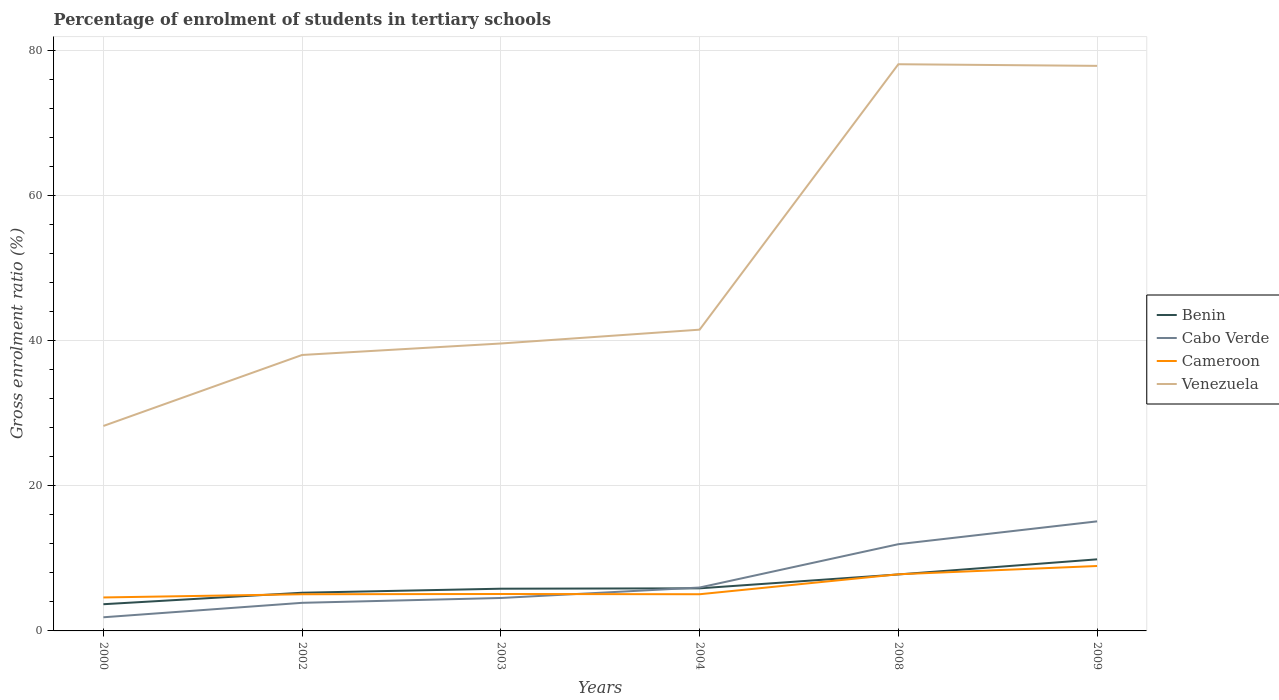Does the line corresponding to Cameroon intersect with the line corresponding to Venezuela?
Provide a succinct answer. No. Is the number of lines equal to the number of legend labels?
Provide a short and direct response. Yes. Across all years, what is the maximum percentage of students enrolled in tertiary schools in Venezuela?
Keep it short and to the point. 28.26. In which year was the percentage of students enrolled in tertiary schools in Venezuela maximum?
Give a very brief answer. 2000. What is the total percentage of students enrolled in tertiary schools in Venezuela in the graph?
Make the answer very short. -36.6. What is the difference between the highest and the second highest percentage of students enrolled in tertiary schools in Cameroon?
Make the answer very short. 4.34. What is the difference between the highest and the lowest percentage of students enrolled in tertiary schools in Benin?
Your answer should be very brief. 2. Is the percentage of students enrolled in tertiary schools in Cabo Verde strictly greater than the percentage of students enrolled in tertiary schools in Benin over the years?
Keep it short and to the point. No. How many lines are there?
Make the answer very short. 4. What is the difference between two consecutive major ticks on the Y-axis?
Your response must be concise. 20. How many legend labels are there?
Offer a terse response. 4. How are the legend labels stacked?
Provide a succinct answer. Vertical. What is the title of the graph?
Provide a succinct answer. Percentage of enrolment of students in tertiary schools. What is the label or title of the X-axis?
Your answer should be compact. Years. What is the label or title of the Y-axis?
Offer a terse response. Gross enrolment ratio (%). What is the Gross enrolment ratio (%) in Benin in 2000?
Provide a succinct answer. 3.68. What is the Gross enrolment ratio (%) in Cabo Verde in 2000?
Offer a terse response. 1.88. What is the Gross enrolment ratio (%) of Cameroon in 2000?
Keep it short and to the point. 4.61. What is the Gross enrolment ratio (%) of Venezuela in 2000?
Your answer should be compact. 28.26. What is the Gross enrolment ratio (%) of Benin in 2002?
Ensure brevity in your answer.  5.26. What is the Gross enrolment ratio (%) in Cabo Verde in 2002?
Provide a short and direct response. 3.87. What is the Gross enrolment ratio (%) of Cameroon in 2002?
Offer a very short reply. 5.06. What is the Gross enrolment ratio (%) of Venezuela in 2002?
Your response must be concise. 38.05. What is the Gross enrolment ratio (%) of Benin in 2003?
Offer a very short reply. 5.82. What is the Gross enrolment ratio (%) in Cabo Verde in 2003?
Ensure brevity in your answer.  4.54. What is the Gross enrolment ratio (%) in Cameroon in 2003?
Give a very brief answer. 5.09. What is the Gross enrolment ratio (%) in Venezuela in 2003?
Provide a short and direct response. 39.63. What is the Gross enrolment ratio (%) in Benin in 2004?
Your answer should be very brief. 5.87. What is the Gross enrolment ratio (%) in Cabo Verde in 2004?
Offer a terse response. 5.98. What is the Gross enrolment ratio (%) in Cameroon in 2004?
Ensure brevity in your answer.  5.06. What is the Gross enrolment ratio (%) of Venezuela in 2004?
Keep it short and to the point. 41.54. What is the Gross enrolment ratio (%) in Benin in 2008?
Your answer should be very brief. 7.79. What is the Gross enrolment ratio (%) of Cabo Verde in 2008?
Your response must be concise. 11.96. What is the Gross enrolment ratio (%) of Cameroon in 2008?
Offer a terse response. 7.81. What is the Gross enrolment ratio (%) in Venezuela in 2008?
Offer a terse response. 78.13. What is the Gross enrolment ratio (%) of Benin in 2009?
Offer a terse response. 9.87. What is the Gross enrolment ratio (%) of Cabo Verde in 2009?
Offer a terse response. 15.11. What is the Gross enrolment ratio (%) of Cameroon in 2009?
Offer a very short reply. 8.95. What is the Gross enrolment ratio (%) of Venezuela in 2009?
Offer a terse response. 77.91. Across all years, what is the maximum Gross enrolment ratio (%) in Benin?
Offer a terse response. 9.87. Across all years, what is the maximum Gross enrolment ratio (%) of Cabo Verde?
Give a very brief answer. 15.11. Across all years, what is the maximum Gross enrolment ratio (%) in Cameroon?
Keep it short and to the point. 8.95. Across all years, what is the maximum Gross enrolment ratio (%) in Venezuela?
Give a very brief answer. 78.13. Across all years, what is the minimum Gross enrolment ratio (%) of Benin?
Provide a short and direct response. 3.68. Across all years, what is the minimum Gross enrolment ratio (%) of Cabo Verde?
Offer a very short reply. 1.88. Across all years, what is the minimum Gross enrolment ratio (%) in Cameroon?
Provide a short and direct response. 4.61. Across all years, what is the minimum Gross enrolment ratio (%) in Venezuela?
Make the answer very short. 28.26. What is the total Gross enrolment ratio (%) of Benin in the graph?
Your answer should be very brief. 38.3. What is the total Gross enrolment ratio (%) in Cabo Verde in the graph?
Your answer should be compact. 43.35. What is the total Gross enrolment ratio (%) in Cameroon in the graph?
Ensure brevity in your answer.  36.58. What is the total Gross enrolment ratio (%) of Venezuela in the graph?
Ensure brevity in your answer.  303.52. What is the difference between the Gross enrolment ratio (%) of Benin in 2000 and that in 2002?
Your answer should be very brief. -1.58. What is the difference between the Gross enrolment ratio (%) of Cabo Verde in 2000 and that in 2002?
Make the answer very short. -1.99. What is the difference between the Gross enrolment ratio (%) in Cameroon in 2000 and that in 2002?
Keep it short and to the point. -0.44. What is the difference between the Gross enrolment ratio (%) of Venezuela in 2000 and that in 2002?
Provide a short and direct response. -9.79. What is the difference between the Gross enrolment ratio (%) in Benin in 2000 and that in 2003?
Provide a succinct answer. -2.14. What is the difference between the Gross enrolment ratio (%) of Cabo Verde in 2000 and that in 2003?
Your response must be concise. -2.66. What is the difference between the Gross enrolment ratio (%) in Cameroon in 2000 and that in 2003?
Provide a short and direct response. -0.48. What is the difference between the Gross enrolment ratio (%) in Venezuela in 2000 and that in 2003?
Make the answer very short. -11.37. What is the difference between the Gross enrolment ratio (%) in Benin in 2000 and that in 2004?
Your answer should be very brief. -2.19. What is the difference between the Gross enrolment ratio (%) in Cabo Verde in 2000 and that in 2004?
Give a very brief answer. -4.1. What is the difference between the Gross enrolment ratio (%) in Cameroon in 2000 and that in 2004?
Provide a short and direct response. -0.44. What is the difference between the Gross enrolment ratio (%) of Venezuela in 2000 and that in 2004?
Provide a short and direct response. -13.28. What is the difference between the Gross enrolment ratio (%) in Benin in 2000 and that in 2008?
Your answer should be compact. -4.11. What is the difference between the Gross enrolment ratio (%) of Cabo Verde in 2000 and that in 2008?
Give a very brief answer. -10.08. What is the difference between the Gross enrolment ratio (%) of Cameroon in 2000 and that in 2008?
Make the answer very short. -3.19. What is the difference between the Gross enrolment ratio (%) of Venezuela in 2000 and that in 2008?
Keep it short and to the point. -49.88. What is the difference between the Gross enrolment ratio (%) in Benin in 2000 and that in 2009?
Your response must be concise. -6.19. What is the difference between the Gross enrolment ratio (%) of Cabo Verde in 2000 and that in 2009?
Give a very brief answer. -13.22. What is the difference between the Gross enrolment ratio (%) of Cameroon in 2000 and that in 2009?
Ensure brevity in your answer.  -4.34. What is the difference between the Gross enrolment ratio (%) of Venezuela in 2000 and that in 2009?
Ensure brevity in your answer.  -49.65. What is the difference between the Gross enrolment ratio (%) of Benin in 2002 and that in 2003?
Your response must be concise. -0.56. What is the difference between the Gross enrolment ratio (%) of Cabo Verde in 2002 and that in 2003?
Give a very brief answer. -0.67. What is the difference between the Gross enrolment ratio (%) of Cameroon in 2002 and that in 2003?
Your response must be concise. -0.03. What is the difference between the Gross enrolment ratio (%) of Venezuela in 2002 and that in 2003?
Your answer should be compact. -1.58. What is the difference between the Gross enrolment ratio (%) of Benin in 2002 and that in 2004?
Your response must be concise. -0.61. What is the difference between the Gross enrolment ratio (%) in Cabo Verde in 2002 and that in 2004?
Your response must be concise. -2.11. What is the difference between the Gross enrolment ratio (%) in Cameroon in 2002 and that in 2004?
Offer a very short reply. -0. What is the difference between the Gross enrolment ratio (%) of Venezuela in 2002 and that in 2004?
Offer a terse response. -3.49. What is the difference between the Gross enrolment ratio (%) in Benin in 2002 and that in 2008?
Provide a short and direct response. -2.52. What is the difference between the Gross enrolment ratio (%) in Cabo Verde in 2002 and that in 2008?
Provide a short and direct response. -8.08. What is the difference between the Gross enrolment ratio (%) in Cameroon in 2002 and that in 2008?
Give a very brief answer. -2.75. What is the difference between the Gross enrolment ratio (%) in Venezuela in 2002 and that in 2008?
Make the answer very short. -40.09. What is the difference between the Gross enrolment ratio (%) of Benin in 2002 and that in 2009?
Your answer should be compact. -4.61. What is the difference between the Gross enrolment ratio (%) in Cabo Verde in 2002 and that in 2009?
Give a very brief answer. -11.23. What is the difference between the Gross enrolment ratio (%) in Cameroon in 2002 and that in 2009?
Give a very brief answer. -3.9. What is the difference between the Gross enrolment ratio (%) in Venezuela in 2002 and that in 2009?
Your response must be concise. -39.86. What is the difference between the Gross enrolment ratio (%) in Benin in 2003 and that in 2004?
Ensure brevity in your answer.  -0.05. What is the difference between the Gross enrolment ratio (%) of Cabo Verde in 2003 and that in 2004?
Your answer should be very brief. -1.44. What is the difference between the Gross enrolment ratio (%) of Cameroon in 2003 and that in 2004?
Provide a short and direct response. 0.03. What is the difference between the Gross enrolment ratio (%) of Venezuela in 2003 and that in 2004?
Your answer should be compact. -1.91. What is the difference between the Gross enrolment ratio (%) of Benin in 2003 and that in 2008?
Offer a terse response. -1.97. What is the difference between the Gross enrolment ratio (%) in Cabo Verde in 2003 and that in 2008?
Give a very brief answer. -7.42. What is the difference between the Gross enrolment ratio (%) in Cameroon in 2003 and that in 2008?
Provide a short and direct response. -2.72. What is the difference between the Gross enrolment ratio (%) of Venezuela in 2003 and that in 2008?
Your response must be concise. -38.51. What is the difference between the Gross enrolment ratio (%) in Benin in 2003 and that in 2009?
Provide a succinct answer. -4.05. What is the difference between the Gross enrolment ratio (%) in Cabo Verde in 2003 and that in 2009?
Ensure brevity in your answer.  -10.56. What is the difference between the Gross enrolment ratio (%) of Cameroon in 2003 and that in 2009?
Offer a very short reply. -3.86. What is the difference between the Gross enrolment ratio (%) in Venezuela in 2003 and that in 2009?
Provide a succinct answer. -38.28. What is the difference between the Gross enrolment ratio (%) of Benin in 2004 and that in 2008?
Keep it short and to the point. -1.92. What is the difference between the Gross enrolment ratio (%) of Cabo Verde in 2004 and that in 2008?
Give a very brief answer. -5.97. What is the difference between the Gross enrolment ratio (%) in Cameroon in 2004 and that in 2008?
Offer a terse response. -2.75. What is the difference between the Gross enrolment ratio (%) in Venezuela in 2004 and that in 2008?
Offer a very short reply. -36.6. What is the difference between the Gross enrolment ratio (%) in Benin in 2004 and that in 2009?
Ensure brevity in your answer.  -4. What is the difference between the Gross enrolment ratio (%) of Cabo Verde in 2004 and that in 2009?
Offer a terse response. -9.12. What is the difference between the Gross enrolment ratio (%) of Cameroon in 2004 and that in 2009?
Offer a terse response. -3.89. What is the difference between the Gross enrolment ratio (%) in Venezuela in 2004 and that in 2009?
Make the answer very short. -36.37. What is the difference between the Gross enrolment ratio (%) in Benin in 2008 and that in 2009?
Your response must be concise. -2.08. What is the difference between the Gross enrolment ratio (%) of Cabo Verde in 2008 and that in 2009?
Offer a terse response. -3.15. What is the difference between the Gross enrolment ratio (%) of Cameroon in 2008 and that in 2009?
Provide a short and direct response. -1.14. What is the difference between the Gross enrolment ratio (%) of Venezuela in 2008 and that in 2009?
Your answer should be compact. 0.23. What is the difference between the Gross enrolment ratio (%) of Benin in 2000 and the Gross enrolment ratio (%) of Cabo Verde in 2002?
Provide a short and direct response. -0.19. What is the difference between the Gross enrolment ratio (%) of Benin in 2000 and the Gross enrolment ratio (%) of Cameroon in 2002?
Ensure brevity in your answer.  -1.37. What is the difference between the Gross enrolment ratio (%) of Benin in 2000 and the Gross enrolment ratio (%) of Venezuela in 2002?
Provide a short and direct response. -34.37. What is the difference between the Gross enrolment ratio (%) of Cabo Verde in 2000 and the Gross enrolment ratio (%) of Cameroon in 2002?
Provide a short and direct response. -3.17. What is the difference between the Gross enrolment ratio (%) of Cabo Verde in 2000 and the Gross enrolment ratio (%) of Venezuela in 2002?
Keep it short and to the point. -36.17. What is the difference between the Gross enrolment ratio (%) in Cameroon in 2000 and the Gross enrolment ratio (%) in Venezuela in 2002?
Give a very brief answer. -33.43. What is the difference between the Gross enrolment ratio (%) of Benin in 2000 and the Gross enrolment ratio (%) of Cabo Verde in 2003?
Your answer should be very brief. -0.86. What is the difference between the Gross enrolment ratio (%) in Benin in 2000 and the Gross enrolment ratio (%) in Cameroon in 2003?
Your response must be concise. -1.41. What is the difference between the Gross enrolment ratio (%) in Benin in 2000 and the Gross enrolment ratio (%) in Venezuela in 2003?
Provide a succinct answer. -35.95. What is the difference between the Gross enrolment ratio (%) in Cabo Verde in 2000 and the Gross enrolment ratio (%) in Cameroon in 2003?
Make the answer very short. -3.21. What is the difference between the Gross enrolment ratio (%) of Cabo Verde in 2000 and the Gross enrolment ratio (%) of Venezuela in 2003?
Provide a succinct answer. -37.75. What is the difference between the Gross enrolment ratio (%) of Cameroon in 2000 and the Gross enrolment ratio (%) of Venezuela in 2003?
Your answer should be very brief. -35.01. What is the difference between the Gross enrolment ratio (%) of Benin in 2000 and the Gross enrolment ratio (%) of Cabo Verde in 2004?
Offer a very short reply. -2.3. What is the difference between the Gross enrolment ratio (%) of Benin in 2000 and the Gross enrolment ratio (%) of Cameroon in 2004?
Ensure brevity in your answer.  -1.38. What is the difference between the Gross enrolment ratio (%) of Benin in 2000 and the Gross enrolment ratio (%) of Venezuela in 2004?
Your answer should be very brief. -37.86. What is the difference between the Gross enrolment ratio (%) in Cabo Verde in 2000 and the Gross enrolment ratio (%) in Cameroon in 2004?
Your response must be concise. -3.18. What is the difference between the Gross enrolment ratio (%) of Cabo Verde in 2000 and the Gross enrolment ratio (%) of Venezuela in 2004?
Offer a terse response. -39.66. What is the difference between the Gross enrolment ratio (%) of Cameroon in 2000 and the Gross enrolment ratio (%) of Venezuela in 2004?
Your response must be concise. -36.92. What is the difference between the Gross enrolment ratio (%) in Benin in 2000 and the Gross enrolment ratio (%) in Cabo Verde in 2008?
Give a very brief answer. -8.28. What is the difference between the Gross enrolment ratio (%) of Benin in 2000 and the Gross enrolment ratio (%) of Cameroon in 2008?
Your answer should be compact. -4.13. What is the difference between the Gross enrolment ratio (%) in Benin in 2000 and the Gross enrolment ratio (%) in Venezuela in 2008?
Your answer should be compact. -74.45. What is the difference between the Gross enrolment ratio (%) in Cabo Verde in 2000 and the Gross enrolment ratio (%) in Cameroon in 2008?
Your answer should be compact. -5.93. What is the difference between the Gross enrolment ratio (%) of Cabo Verde in 2000 and the Gross enrolment ratio (%) of Venezuela in 2008?
Provide a short and direct response. -76.25. What is the difference between the Gross enrolment ratio (%) of Cameroon in 2000 and the Gross enrolment ratio (%) of Venezuela in 2008?
Your response must be concise. -73.52. What is the difference between the Gross enrolment ratio (%) in Benin in 2000 and the Gross enrolment ratio (%) in Cabo Verde in 2009?
Your answer should be compact. -11.43. What is the difference between the Gross enrolment ratio (%) of Benin in 2000 and the Gross enrolment ratio (%) of Cameroon in 2009?
Offer a very short reply. -5.27. What is the difference between the Gross enrolment ratio (%) in Benin in 2000 and the Gross enrolment ratio (%) in Venezuela in 2009?
Make the answer very short. -74.23. What is the difference between the Gross enrolment ratio (%) of Cabo Verde in 2000 and the Gross enrolment ratio (%) of Cameroon in 2009?
Provide a succinct answer. -7.07. What is the difference between the Gross enrolment ratio (%) of Cabo Verde in 2000 and the Gross enrolment ratio (%) of Venezuela in 2009?
Offer a very short reply. -76.03. What is the difference between the Gross enrolment ratio (%) of Cameroon in 2000 and the Gross enrolment ratio (%) of Venezuela in 2009?
Provide a short and direct response. -73.3. What is the difference between the Gross enrolment ratio (%) in Benin in 2002 and the Gross enrolment ratio (%) in Cabo Verde in 2003?
Ensure brevity in your answer.  0.72. What is the difference between the Gross enrolment ratio (%) of Benin in 2002 and the Gross enrolment ratio (%) of Cameroon in 2003?
Your answer should be compact. 0.17. What is the difference between the Gross enrolment ratio (%) in Benin in 2002 and the Gross enrolment ratio (%) in Venezuela in 2003?
Give a very brief answer. -34.36. What is the difference between the Gross enrolment ratio (%) in Cabo Verde in 2002 and the Gross enrolment ratio (%) in Cameroon in 2003?
Give a very brief answer. -1.22. What is the difference between the Gross enrolment ratio (%) of Cabo Verde in 2002 and the Gross enrolment ratio (%) of Venezuela in 2003?
Offer a very short reply. -35.75. What is the difference between the Gross enrolment ratio (%) in Cameroon in 2002 and the Gross enrolment ratio (%) in Venezuela in 2003?
Your response must be concise. -34.57. What is the difference between the Gross enrolment ratio (%) in Benin in 2002 and the Gross enrolment ratio (%) in Cabo Verde in 2004?
Provide a short and direct response. -0.72. What is the difference between the Gross enrolment ratio (%) in Benin in 2002 and the Gross enrolment ratio (%) in Cameroon in 2004?
Ensure brevity in your answer.  0.21. What is the difference between the Gross enrolment ratio (%) of Benin in 2002 and the Gross enrolment ratio (%) of Venezuela in 2004?
Provide a short and direct response. -36.27. What is the difference between the Gross enrolment ratio (%) of Cabo Verde in 2002 and the Gross enrolment ratio (%) of Cameroon in 2004?
Provide a short and direct response. -1.18. What is the difference between the Gross enrolment ratio (%) in Cabo Verde in 2002 and the Gross enrolment ratio (%) in Venezuela in 2004?
Offer a very short reply. -37.66. What is the difference between the Gross enrolment ratio (%) of Cameroon in 2002 and the Gross enrolment ratio (%) of Venezuela in 2004?
Ensure brevity in your answer.  -36.48. What is the difference between the Gross enrolment ratio (%) in Benin in 2002 and the Gross enrolment ratio (%) in Cabo Verde in 2008?
Keep it short and to the point. -6.69. What is the difference between the Gross enrolment ratio (%) in Benin in 2002 and the Gross enrolment ratio (%) in Cameroon in 2008?
Provide a succinct answer. -2.54. What is the difference between the Gross enrolment ratio (%) in Benin in 2002 and the Gross enrolment ratio (%) in Venezuela in 2008?
Offer a terse response. -72.87. What is the difference between the Gross enrolment ratio (%) of Cabo Verde in 2002 and the Gross enrolment ratio (%) of Cameroon in 2008?
Your response must be concise. -3.93. What is the difference between the Gross enrolment ratio (%) of Cabo Verde in 2002 and the Gross enrolment ratio (%) of Venezuela in 2008?
Your answer should be very brief. -74.26. What is the difference between the Gross enrolment ratio (%) in Cameroon in 2002 and the Gross enrolment ratio (%) in Venezuela in 2008?
Keep it short and to the point. -73.08. What is the difference between the Gross enrolment ratio (%) of Benin in 2002 and the Gross enrolment ratio (%) of Cabo Verde in 2009?
Make the answer very short. -9.84. What is the difference between the Gross enrolment ratio (%) in Benin in 2002 and the Gross enrolment ratio (%) in Cameroon in 2009?
Offer a terse response. -3.69. What is the difference between the Gross enrolment ratio (%) of Benin in 2002 and the Gross enrolment ratio (%) of Venezuela in 2009?
Provide a short and direct response. -72.64. What is the difference between the Gross enrolment ratio (%) in Cabo Verde in 2002 and the Gross enrolment ratio (%) in Cameroon in 2009?
Your answer should be compact. -5.08. What is the difference between the Gross enrolment ratio (%) in Cabo Verde in 2002 and the Gross enrolment ratio (%) in Venezuela in 2009?
Your answer should be compact. -74.03. What is the difference between the Gross enrolment ratio (%) in Cameroon in 2002 and the Gross enrolment ratio (%) in Venezuela in 2009?
Offer a terse response. -72.85. What is the difference between the Gross enrolment ratio (%) of Benin in 2003 and the Gross enrolment ratio (%) of Cabo Verde in 2004?
Your answer should be very brief. -0.16. What is the difference between the Gross enrolment ratio (%) in Benin in 2003 and the Gross enrolment ratio (%) in Cameroon in 2004?
Your answer should be compact. 0.76. What is the difference between the Gross enrolment ratio (%) of Benin in 2003 and the Gross enrolment ratio (%) of Venezuela in 2004?
Make the answer very short. -35.72. What is the difference between the Gross enrolment ratio (%) in Cabo Verde in 2003 and the Gross enrolment ratio (%) in Cameroon in 2004?
Offer a very short reply. -0.52. What is the difference between the Gross enrolment ratio (%) of Cabo Verde in 2003 and the Gross enrolment ratio (%) of Venezuela in 2004?
Your response must be concise. -37. What is the difference between the Gross enrolment ratio (%) in Cameroon in 2003 and the Gross enrolment ratio (%) in Venezuela in 2004?
Offer a very short reply. -36.45. What is the difference between the Gross enrolment ratio (%) in Benin in 2003 and the Gross enrolment ratio (%) in Cabo Verde in 2008?
Offer a terse response. -6.14. What is the difference between the Gross enrolment ratio (%) in Benin in 2003 and the Gross enrolment ratio (%) in Cameroon in 2008?
Give a very brief answer. -1.99. What is the difference between the Gross enrolment ratio (%) in Benin in 2003 and the Gross enrolment ratio (%) in Venezuela in 2008?
Offer a terse response. -72.31. What is the difference between the Gross enrolment ratio (%) in Cabo Verde in 2003 and the Gross enrolment ratio (%) in Cameroon in 2008?
Make the answer very short. -3.27. What is the difference between the Gross enrolment ratio (%) in Cabo Verde in 2003 and the Gross enrolment ratio (%) in Venezuela in 2008?
Offer a terse response. -73.59. What is the difference between the Gross enrolment ratio (%) in Cameroon in 2003 and the Gross enrolment ratio (%) in Venezuela in 2008?
Ensure brevity in your answer.  -73.04. What is the difference between the Gross enrolment ratio (%) in Benin in 2003 and the Gross enrolment ratio (%) in Cabo Verde in 2009?
Give a very brief answer. -9.29. What is the difference between the Gross enrolment ratio (%) in Benin in 2003 and the Gross enrolment ratio (%) in Cameroon in 2009?
Ensure brevity in your answer.  -3.13. What is the difference between the Gross enrolment ratio (%) in Benin in 2003 and the Gross enrolment ratio (%) in Venezuela in 2009?
Make the answer very short. -72.09. What is the difference between the Gross enrolment ratio (%) in Cabo Verde in 2003 and the Gross enrolment ratio (%) in Cameroon in 2009?
Give a very brief answer. -4.41. What is the difference between the Gross enrolment ratio (%) of Cabo Verde in 2003 and the Gross enrolment ratio (%) of Venezuela in 2009?
Give a very brief answer. -73.37. What is the difference between the Gross enrolment ratio (%) of Cameroon in 2003 and the Gross enrolment ratio (%) of Venezuela in 2009?
Your answer should be very brief. -72.82. What is the difference between the Gross enrolment ratio (%) in Benin in 2004 and the Gross enrolment ratio (%) in Cabo Verde in 2008?
Offer a very short reply. -6.09. What is the difference between the Gross enrolment ratio (%) in Benin in 2004 and the Gross enrolment ratio (%) in Cameroon in 2008?
Provide a succinct answer. -1.94. What is the difference between the Gross enrolment ratio (%) in Benin in 2004 and the Gross enrolment ratio (%) in Venezuela in 2008?
Your answer should be compact. -72.26. What is the difference between the Gross enrolment ratio (%) of Cabo Verde in 2004 and the Gross enrolment ratio (%) of Cameroon in 2008?
Offer a very short reply. -1.82. What is the difference between the Gross enrolment ratio (%) of Cabo Verde in 2004 and the Gross enrolment ratio (%) of Venezuela in 2008?
Keep it short and to the point. -72.15. What is the difference between the Gross enrolment ratio (%) of Cameroon in 2004 and the Gross enrolment ratio (%) of Venezuela in 2008?
Your answer should be very brief. -73.08. What is the difference between the Gross enrolment ratio (%) in Benin in 2004 and the Gross enrolment ratio (%) in Cabo Verde in 2009?
Provide a succinct answer. -9.23. What is the difference between the Gross enrolment ratio (%) of Benin in 2004 and the Gross enrolment ratio (%) of Cameroon in 2009?
Your answer should be very brief. -3.08. What is the difference between the Gross enrolment ratio (%) in Benin in 2004 and the Gross enrolment ratio (%) in Venezuela in 2009?
Make the answer very short. -72.04. What is the difference between the Gross enrolment ratio (%) in Cabo Verde in 2004 and the Gross enrolment ratio (%) in Cameroon in 2009?
Your answer should be compact. -2.97. What is the difference between the Gross enrolment ratio (%) in Cabo Verde in 2004 and the Gross enrolment ratio (%) in Venezuela in 2009?
Provide a succinct answer. -71.93. What is the difference between the Gross enrolment ratio (%) of Cameroon in 2004 and the Gross enrolment ratio (%) of Venezuela in 2009?
Give a very brief answer. -72.85. What is the difference between the Gross enrolment ratio (%) in Benin in 2008 and the Gross enrolment ratio (%) in Cabo Verde in 2009?
Provide a succinct answer. -7.32. What is the difference between the Gross enrolment ratio (%) in Benin in 2008 and the Gross enrolment ratio (%) in Cameroon in 2009?
Keep it short and to the point. -1.16. What is the difference between the Gross enrolment ratio (%) of Benin in 2008 and the Gross enrolment ratio (%) of Venezuela in 2009?
Give a very brief answer. -70.12. What is the difference between the Gross enrolment ratio (%) of Cabo Verde in 2008 and the Gross enrolment ratio (%) of Cameroon in 2009?
Keep it short and to the point. 3.01. What is the difference between the Gross enrolment ratio (%) in Cabo Verde in 2008 and the Gross enrolment ratio (%) in Venezuela in 2009?
Your answer should be very brief. -65.95. What is the difference between the Gross enrolment ratio (%) of Cameroon in 2008 and the Gross enrolment ratio (%) of Venezuela in 2009?
Make the answer very short. -70.1. What is the average Gross enrolment ratio (%) in Benin per year?
Provide a succinct answer. 6.38. What is the average Gross enrolment ratio (%) in Cabo Verde per year?
Offer a very short reply. 7.22. What is the average Gross enrolment ratio (%) in Cameroon per year?
Keep it short and to the point. 6.1. What is the average Gross enrolment ratio (%) in Venezuela per year?
Your answer should be compact. 50.59. In the year 2000, what is the difference between the Gross enrolment ratio (%) in Benin and Gross enrolment ratio (%) in Cabo Verde?
Keep it short and to the point. 1.8. In the year 2000, what is the difference between the Gross enrolment ratio (%) in Benin and Gross enrolment ratio (%) in Cameroon?
Your answer should be very brief. -0.93. In the year 2000, what is the difference between the Gross enrolment ratio (%) of Benin and Gross enrolment ratio (%) of Venezuela?
Provide a short and direct response. -24.58. In the year 2000, what is the difference between the Gross enrolment ratio (%) in Cabo Verde and Gross enrolment ratio (%) in Cameroon?
Your response must be concise. -2.73. In the year 2000, what is the difference between the Gross enrolment ratio (%) of Cabo Verde and Gross enrolment ratio (%) of Venezuela?
Keep it short and to the point. -26.38. In the year 2000, what is the difference between the Gross enrolment ratio (%) in Cameroon and Gross enrolment ratio (%) in Venezuela?
Ensure brevity in your answer.  -23.64. In the year 2002, what is the difference between the Gross enrolment ratio (%) in Benin and Gross enrolment ratio (%) in Cabo Verde?
Your answer should be compact. 1.39. In the year 2002, what is the difference between the Gross enrolment ratio (%) of Benin and Gross enrolment ratio (%) of Cameroon?
Ensure brevity in your answer.  0.21. In the year 2002, what is the difference between the Gross enrolment ratio (%) in Benin and Gross enrolment ratio (%) in Venezuela?
Give a very brief answer. -32.78. In the year 2002, what is the difference between the Gross enrolment ratio (%) of Cabo Verde and Gross enrolment ratio (%) of Cameroon?
Provide a succinct answer. -1.18. In the year 2002, what is the difference between the Gross enrolment ratio (%) in Cabo Verde and Gross enrolment ratio (%) in Venezuela?
Keep it short and to the point. -34.17. In the year 2002, what is the difference between the Gross enrolment ratio (%) of Cameroon and Gross enrolment ratio (%) of Venezuela?
Your answer should be very brief. -32.99. In the year 2003, what is the difference between the Gross enrolment ratio (%) in Benin and Gross enrolment ratio (%) in Cabo Verde?
Your answer should be very brief. 1.28. In the year 2003, what is the difference between the Gross enrolment ratio (%) of Benin and Gross enrolment ratio (%) of Cameroon?
Your answer should be compact. 0.73. In the year 2003, what is the difference between the Gross enrolment ratio (%) of Benin and Gross enrolment ratio (%) of Venezuela?
Give a very brief answer. -33.81. In the year 2003, what is the difference between the Gross enrolment ratio (%) in Cabo Verde and Gross enrolment ratio (%) in Cameroon?
Your answer should be very brief. -0.55. In the year 2003, what is the difference between the Gross enrolment ratio (%) of Cabo Verde and Gross enrolment ratio (%) of Venezuela?
Ensure brevity in your answer.  -35.09. In the year 2003, what is the difference between the Gross enrolment ratio (%) in Cameroon and Gross enrolment ratio (%) in Venezuela?
Your answer should be very brief. -34.54. In the year 2004, what is the difference between the Gross enrolment ratio (%) of Benin and Gross enrolment ratio (%) of Cabo Verde?
Provide a succinct answer. -0.11. In the year 2004, what is the difference between the Gross enrolment ratio (%) in Benin and Gross enrolment ratio (%) in Cameroon?
Your response must be concise. 0.81. In the year 2004, what is the difference between the Gross enrolment ratio (%) of Benin and Gross enrolment ratio (%) of Venezuela?
Give a very brief answer. -35.66. In the year 2004, what is the difference between the Gross enrolment ratio (%) of Cabo Verde and Gross enrolment ratio (%) of Cameroon?
Offer a very short reply. 0.93. In the year 2004, what is the difference between the Gross enrolment ratio (%) in Cabo Verde and Gross enrolment ratio (%) in Venezuela?
Your answer should be compact. -35.55. In the year 2004, what is the difference between the Gross enrolment ratio (%) of Cameroon and Gross enrolment ratio (%) of Venezuela?
Offer a terse response. -36.48. In the year 2008, what is the difference between the Gross enrolment ratio (%) of Benin and Gross enrolment ratio (%) of Cabo Verde?
Your response must be concise. -4.17. In the year 2008, what is the difference between the Gross enrolment ratio (%) of Benin and Gross enrolment ratio (%) of Cameroon?
Your answer should be very brief. -0.02. In the year 2008, what is the difference between the Gross enrolment ratio (%) in Benin and Gross enrolment ratio (%) in Venezuela?
Keep it short and to the point. -70.35. In the year 2008, what is the difference between the Gross enrolment ratio (%) in Cabo Verde and Gross enrolment ratio (%) in Cameroon?
Your answer should be very brief. 4.15. In the year 2008, what is the difference between the Gross enrolment ratio (%) of Cabo Verde and Gross enrolment ratio (%) of Venezuela?
Give a very brief answer. -66.18. In the year 2008, what is the difference between the Gross enrolment ratio (%) of Cameroon and Gross enrolment ratio (%) of Venezuela?
Your answer should be compact. -70.33. In the year 2009, what is the difference between the Gross enrolment ratio (%) of Benin and Gross enrolment ratio (%) of Cabo Verde?
Your answer should be compact. -5.24. In the year 2009, what is the difference between the Gross enrolment ratio (%) in Benin and Gross enrolment ratio (%) in Cameroon?
Make the answer very short. 0.92. In the year 2009, what is the difference between the Gross enrolment ratio (%) in Benin and Gross enrolment ratio (%) in Venezuela?
Ensure brevity in your answer.  -68.04. In the year 2009, what is the difference between the Gross enrolment ratio (%) in Cabo Verde and Gross enrolment ratio (%) in Cameroon?
Give a very brief answer. 6.15. In the year 2009, what is the difference between the Gross enrolment ratio (%) in Cabo Verde and Gross enrolment ratio (%) in Venezuela?
Give a very brief answer. -62.8. In the year 2009, what is the difference between the Gross enrolment ratio (%) of Cameroon and Gross enrolment ratio (%) of Venezuela?
Offer a very short reply. -68.96. What is the ratio of the Gross enrolment ratio (%) in Benin in 2000 to that in 2002?
Ensure brevity in your answer.  0.7. What is the ratio of the Gross enrolment ratio (%) in Cabo Verde in 2000 to that in 2002?
Your answer should be compact. 0.49. What is the ratio of the Gross enrolment ratio (%) of Cameroon in 2000 to that in 2002?
Make the answer very short. 0.91. What is the ratio of the Gross enrolment ratio (%) of Venezuela in 2000 to that in 2002?
Ensure brevity in your answer.  0.74. What is the ratio of the Gross enrolment ratio (%) of Benin in 2000 to that in 2003?
Offer a very short reply. 0.63. What is the ratio of the Gross enrolment ratio (%) in Cabo Verde in 2000 to that in 2003?
Keep it short and to the point. 0.41. What is the ratio of the Gross enrolment ratio (%) of Cameroon in 2000 to that in 2003?
Provide a succinct answer. 0.91. What is the ratio of the Gross enrolment ratio (%) in Venezuela in 2000 to that in 2003?
Give a very brief answer. 0.71. What is the ratio of the Gross enrolment ratio (%) in Benin in 2000 to that in 2004?
Your response must be concise. 0.63. What is the ratio of the Gross enrolment ratio (%) in Cabo Verde in 2000 to that in 2004?
Your answer should be very brief. 0.31. What is the ratio of the Gross enrolment ratio (%) in Cameroon in 2000 to that in 2004?
Your answer should be compact. 0.91. What is the ratio of the Gross enrolment ratio (%) of Venezuela in 2000 to that in 2004?
Give a very brief answer. 0.68. What is the ratio of the Gross enrolment ratio (%) in Benin in 2000 to that in 2008?
Your answer should be compact. 0.47. What is the ratio of the Gross enrolment ratio (%) of Cabo Verde in 2000 to that in 2008?
Offer a terse response. 0.16. What is the ratio of the Gross enrolment ratio (%) of Cameroon in 2000 to that in 2008?
Provide a short and direct response. 0.59. What is the ratio of the Gross enrolment ratio (%) of Venezuela in 2000 to that in 2008?
Give a very brief answer. 0.36. What is the ratio of the Gross enrolment ratio (%) of Benin in 2000 to that in 2009?
Your answer should be compact. 0.37. What is the ratio of the Gross enrolment ratio (%) of Cabo Verde in 2000 to that in 2009?
Keep it short and to the point. 0.12. What is the ratio of the Gross enrolment ratio (%) in Cameroon in 2000 to that in 2009?
Keep it short and to the point. 0.52. What is the ratio of the Gross enrolment ratio (%) of Venezuela in 2000 to that in 2009?
Your answer should be very brief. 0.36. What is the ratio of the Gross enrolment ratio (%) of Benin in 2002 to that in 2003?
Offer a terse response. 0.9. What is the ratio of the Gross enrolment ratio (%) of Cabo Verde in 2002 to that in 2003?
Give a very brief answer. 0.85. What is the ratio of the Gross enrolment ratio (%) of Cameroon in 2002 to that in 2003?
Your response must be concise. 0.99. What is the ratio of the Gross enrolment ratio (%) in Venezuela in 2002 to that in 2003?
Keep it short and to the point. 0.96. What is the ratio of the Gross enrolment ratio (%) of Benin in 2002 to that in 2004?
Provide a succinct answer. 0.9. What is the ratio of the Gross enrolment ratio (%) in Cabo Verde in 2002 to that in 2004?
Provide a short and direct response. 0.65. What is the ratio of the Gross enrolment ratio (%) in Cameroon in 2002 to that in 2004?
Provide a short and direct response. 1. What is the ratio of the Gross enrolment ratio (%) in Venezuela in 2002 to that in 2004?
Your answer should be very brief. 0.92. What is the ratio of the Gross enrolment ratio (%) in Benin in 2002 to that in 2008?
Your answer should be compact. 0.68. What is the ratio of the Gross enrolment ratio (%) of Cabo Verde in 2002 to that in 2008?
Provide a succinct answer. 0.32. What is the ratio of the Gross enrolment ratio (%) in Cameroon in 2002 to that in 2008?
Offer a very short reply. 0.65. What is the ratio of the Gross enrolment ratio (%) in Venezuela in 2002 to that in 2008?
Make the answer very short. 0.49. What is the ratio of the Gross enrolment ratio (%) of Benin in 2002 to that in 2009?
Offer a terse response. 0.53. What is the ratio of the Gross enrolment ratio (%) in Cabo Verde in 2002 to that in 2009?
Your response must be concise. 0.26. What is the ratio of the Gross enrolment ratio (%) of Cameroon in 2002 to that in 2009?
Make the answer very short. 0.56. What is the ratio of the Gross enrolment ratio (%) in Venezuela in 2002 to that in 2009?
Your response must be concise. 0.49. What is the ratio of the Gross enrolment ratio (%) of Benin in 2003 to that in 2004?
Offer a terse response. 0.99. What is the ratio of the Gross enrolment ratio (%) of Cabo Verde in 2003 to that in 2004?
Your response must be concise. 0.76. What is the ratio of the Gross enrolment ratio (%) of Cameroon in 2003 to that in 2004?
Your answer should be compact. 1.01. What is the ratio of the Gross enrolment ratio (%) in Venezuela in 2003 to that in 2004?
Your answer should be compact. 0.95. What is the ratio of the Gross enrolment ratio (%) of Benin in 2003 to that in 2008?
Give a very brief answer. 0.75. What is the ratio of the Gross enrolment ratio (%) of Cabo Verde in 2003 to that in 2008?
Give a very brief answer. 0.38. What is the ratio of the Gross enrolment ratio (%) of Cameroon in 2003 to that in 2008?
Offer a very short reply. 0.65. What is the ratio of the Gross enrolment ratio (%) of Venezuela in 2003 to that in 2008?
Give a very brief answer. 0.51. What is the ratio of the Gross enrolment ratio (%) of Benin in 2003 to that in 2009?
Keep it short and to the point. 0.59. What is the ratio of the Gross enrolment ratio (%) of Cabo Verde in 2003 to that in 2009?
Ensure brevity in your answer.  0.3. What is the ratio of the Gross enrolment ratio (%) of Cameroon in 2003 to that in 2009?
Your answer should be very brief. 0.57. What is the ratio of the Gross enrolment ratio (%) in Venezuela in 2003 to that in 2009?
Provide a succinct answer. 0.51. What is the ratio of the Gross enrolment ratio (%) in Benin in 2004 to that in 2008?
Your answer should be compact. 0.75. What is the ratio of the Gross enrolment ratio (%) of Cabo Verde in 2004 to that in 2008?
Ensure brevity in your answer.  0.5. What is the ratio of the Gross enrolment ratio (%) of Cameroon in 2004 to that in 2008?
Keep it short and to the point. 0.65. What is the ratio of the Gross enrolment ratio (%) of Venezuela in 2004 to that in 2008?
Ensure brevity in your answer.  0.53. What is the ratio of the Gross enrolment ratio (%) in Benin in 2004 to that in 2009?
Your response must be concise. 0.59. What is the ratio of the Gross enrolment ratio (%) in Cabo Verde in 2004 to that in 2009?
Provide a succinct answer. 0.4. What is the ratio of the Gross enrolment ratio (%) in Cameroon in 2004 to that in 2009?
Your answer should be compact. 0.56. What is the ratio of the Gross enrolment ratio (%) of Venezuela in 2004 to that in 2009?
Give a very brief answer. 0.53. What is the ratio of the Gross enrolment ratio (%) of Benin in 2008 to that in 2009?
Provide a succinct answer. 0.79. What is the ratio of the Gross enrolment ratio (%) of Cabo Verde in 2008 to that in 2009?
Provide a succinct answer. 0.79. What is the ratio of the Gross enrolment ratio (%) in Cameroon in 2008 to that in 2009?
Give a very brief answer. 0.87. What is the difference between the highest and the second highest Gross enrolment ratio (%) of Benin?
Offer a terse response. 2.08. What is the difference between the highest and the second highest Gross enrolment ratio (%) in Cabo Verde?
Your answer should be compact. 3.15. What is the difference between the highest and the second highest Gross enrolment ratio (%) in Cameroon?
Provide a succinct answer. 1.14. What is the difference between the highest and the second highest Gross enrolment ratio (%) in Venezuela?
Make the answer very short. 0.23. What is the difference between the highest and the lowest Gross enrolment ratio (%) of Benin?
Ensure brevity in your answer.  6.19. What is the difference between the highest and the lowest Gross enrolment ratio (%) of Cabo Verde?
Provide a short and direct response. 13.22. What is the difference between the highest and the lowest Gross enrolment ratio (%) of Cameroon?
Offer a terse response. 4.34. What is the difference between the highest and the lowest Gross enrolment ratio (%) of Venezuela?
Offer a terse response. 49.88. 